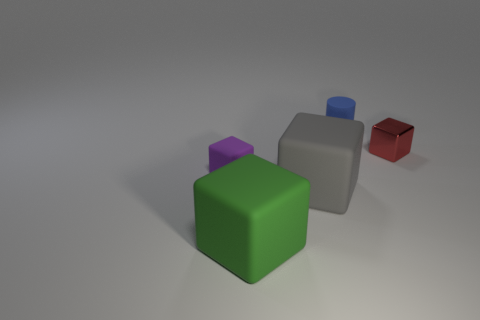Is there anything else that has the same material as the small red thing?
Provide a short and direct response. No. Are there any other things that are the same shape as the small blue thing?
Ensure brevity in your answer.  No. What number of yellow shiny cubes are there?
Your answer should be very brief. 0. What is the shape of the purple object that is the same material as the large green block?
Your response must be concise. Cube. There is a small block that is behind the small purple block; is its color the same as the rubber cube in front of the gray matte thing?
Make the answer very short. No. Are there an equal number of large green matte things left of the green thing and big red rubber balls?
Make the answer very short. Yes. There is a large gray object; what number of large gray rubber blocks are behind it?
Your answer should be very brief. 0. What size is the green matte object?
Provide a short and direct response. Large. What is the color of the small cube that is the same material as the big green block?
Ensure brevity in your answer.  Purple. How many green objects have the same size as the blue rubber cylinder?
Keep it short and to the point. 0. 